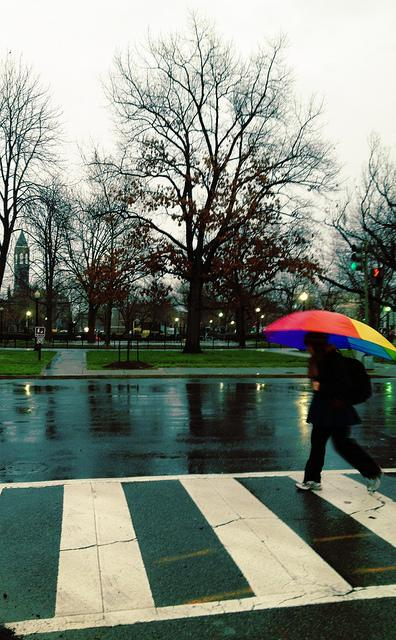What is the person walking on?

Choices:
A) hot coals
B) street
C) dirt road
D) snow street 